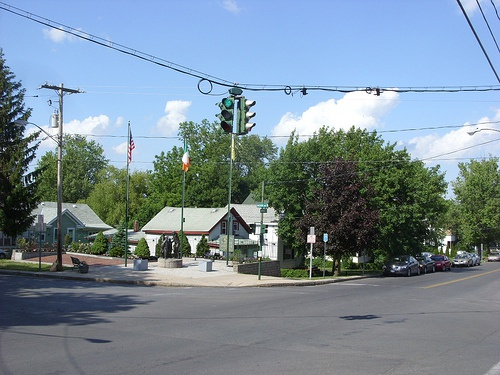Describe the objects in this image and their specific colors. I can see traffic light in lightblue, black, gray, and darkgray tones, car in lightblue, black, and gray tones, car in lightblue, black, gray, and blue tones, car in lightblue, black, gray, navy, and purple tones, and car in lightblue, black, darkgray, gray, and lightgray tones in this image. 